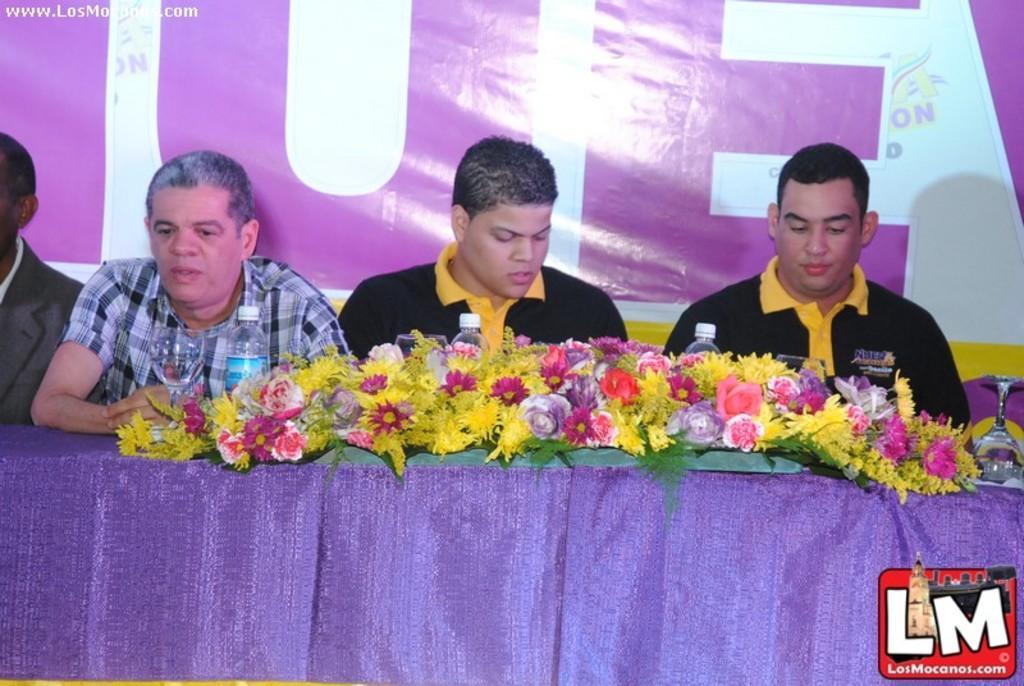In one or two sentences, can you explain what this image depicts? In the background we can see a banner. In the top left corner of the picture we can see watermark. In this picture we can see the men near to a table and on the table we can see the flower bouquets, water bottles and the glasses. In the bottom right corner of the picture we can see the logo. 